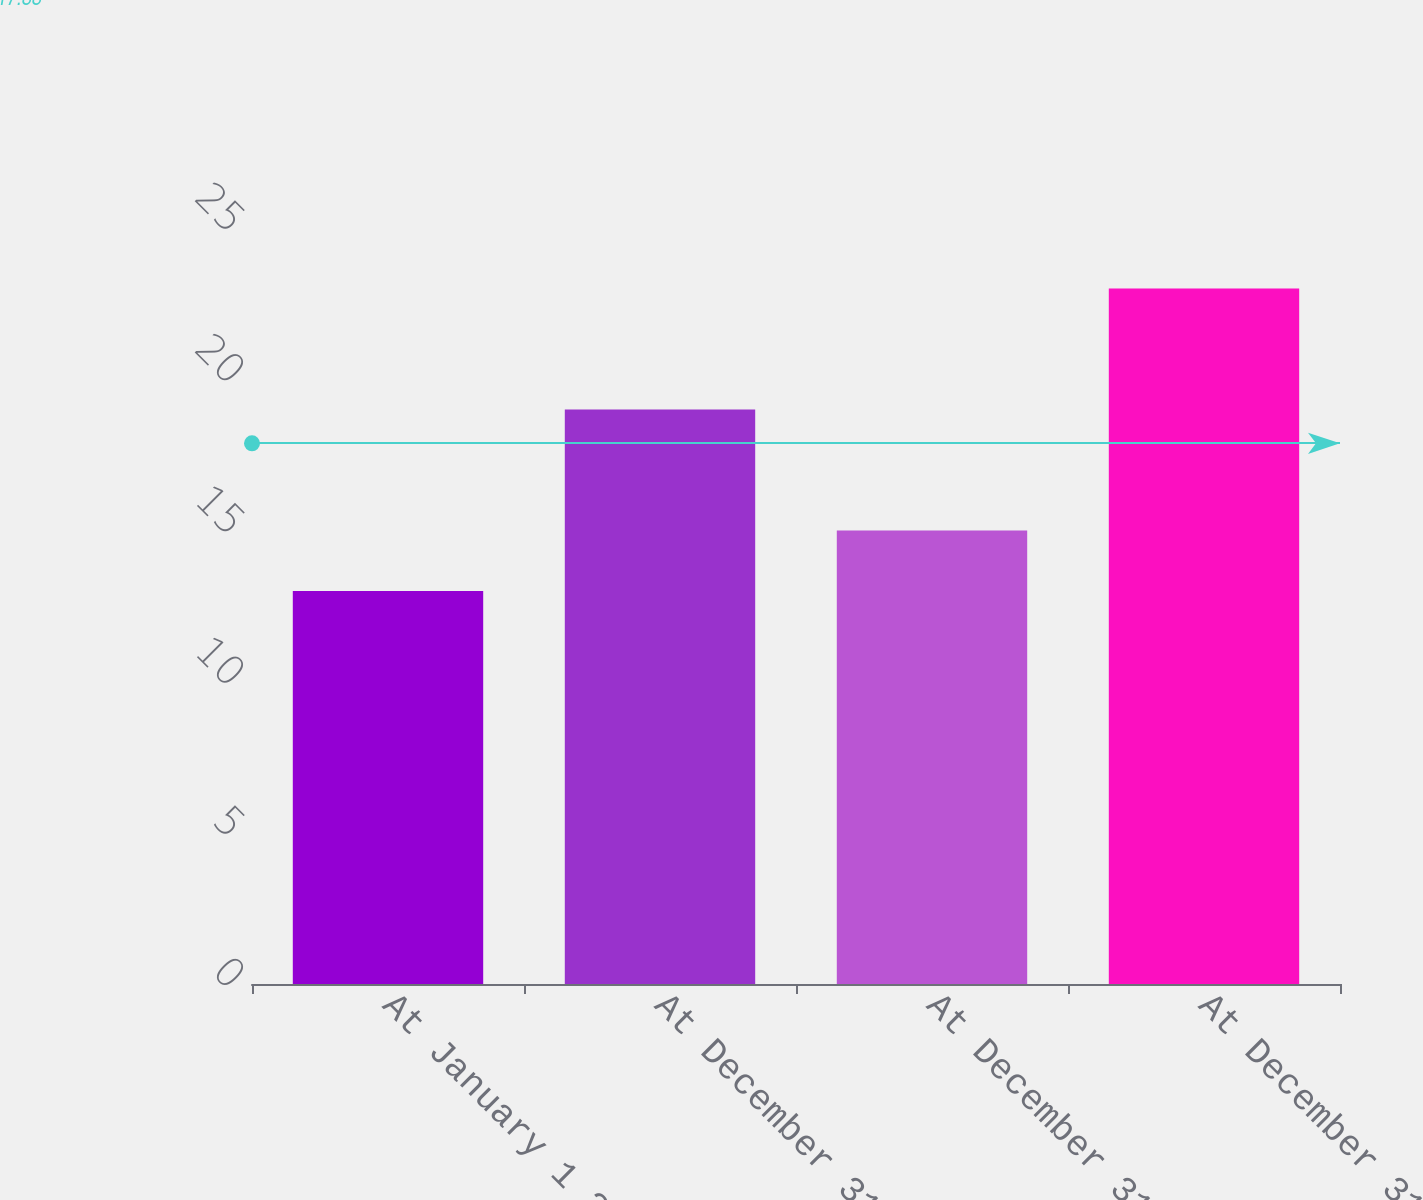<chart> <loc_0><loc_0><loc_500><loc_500><bar_chart><fcel>At January 1 2006<fcel>At December 31 2006<fcel>At December 31 2007<fcel>At December 31 2008<nl><fcel>13<fcel>19<fcel>15<fcel>23<nl></chart> 